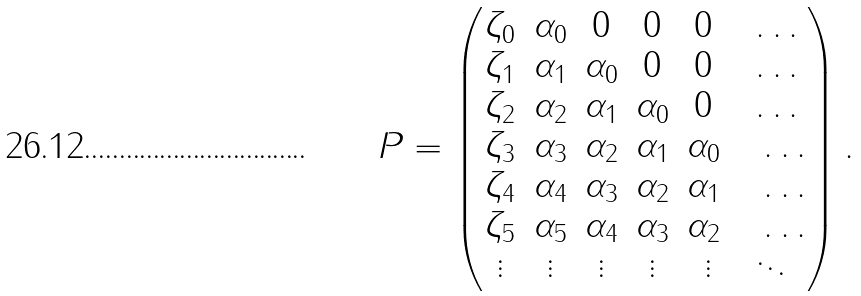Convert formula to latex. <formula><loc_0><loc_0><loc_500><loc_500>P = \begin{pmatrix} \zeta _ { 0 } & \alpha _ { 0 } & 0 & 0 & 0 \quad \dots \\ \zeta _ { 1 } & \alpha _ { 1 } & \alpha _ { 0 } & 0 & 0 \quad \dots \\ \zeta _ { 2 } & \alpha _ { 2 } & \alpha _ { 1 } & \alpha _ { 0 } & 0 \quad \dots \\ \zeta _ { 3 } & \alpha _ { 3 } & \alpha _ { 2 } & \alpha _ { 1 } & \alpha _ { 0 } \quad \dots \\ \zeta _ { 4 } & \alpha _ { 4 } & \alpha _ { 3 } & \alpha _ { 2 } & \alpha _ { 1 } \quad \dots \\ \zeta _ { 5 } & \alpha _ { 5 } & \alpha _ { 4 } & \alpha _ { 3 } & \alpha _ { 2 } \quad \dots \\ \vdots & \vdots & \vdots & \vdots & \vdots \quad \ddots \end{pmatrix} .</formula> 